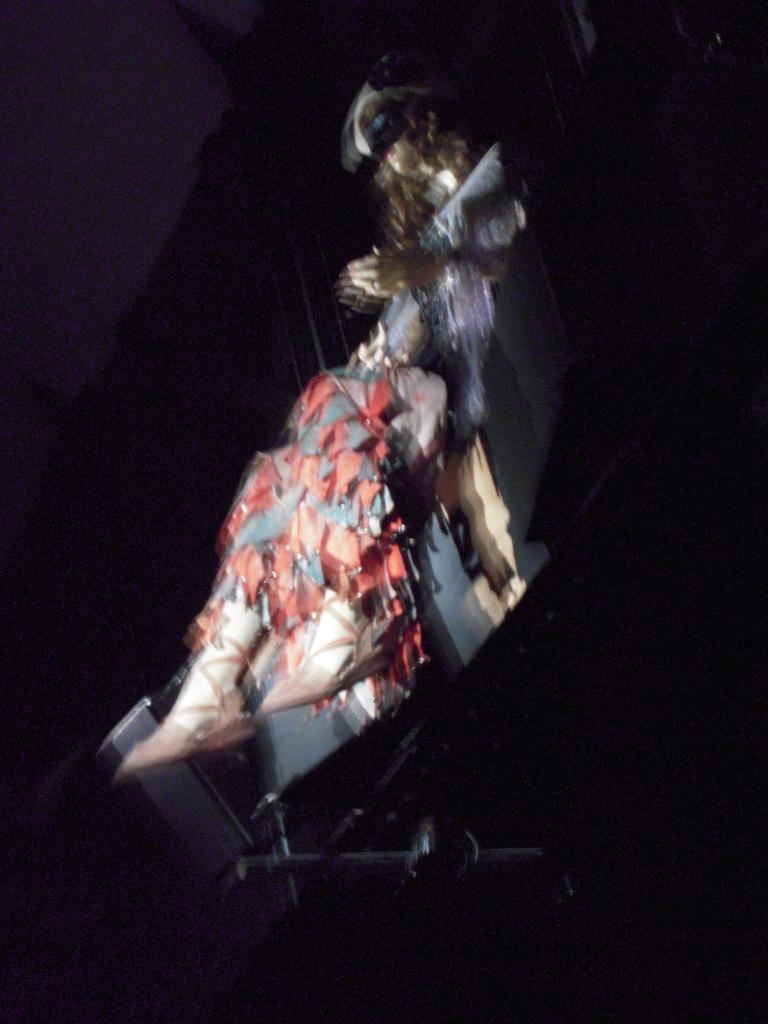Please provide a concise description of this image. In this image I can see the mannequin and I can see the red and grey color cloth on it. It is sitting on some object and there is a black background. 